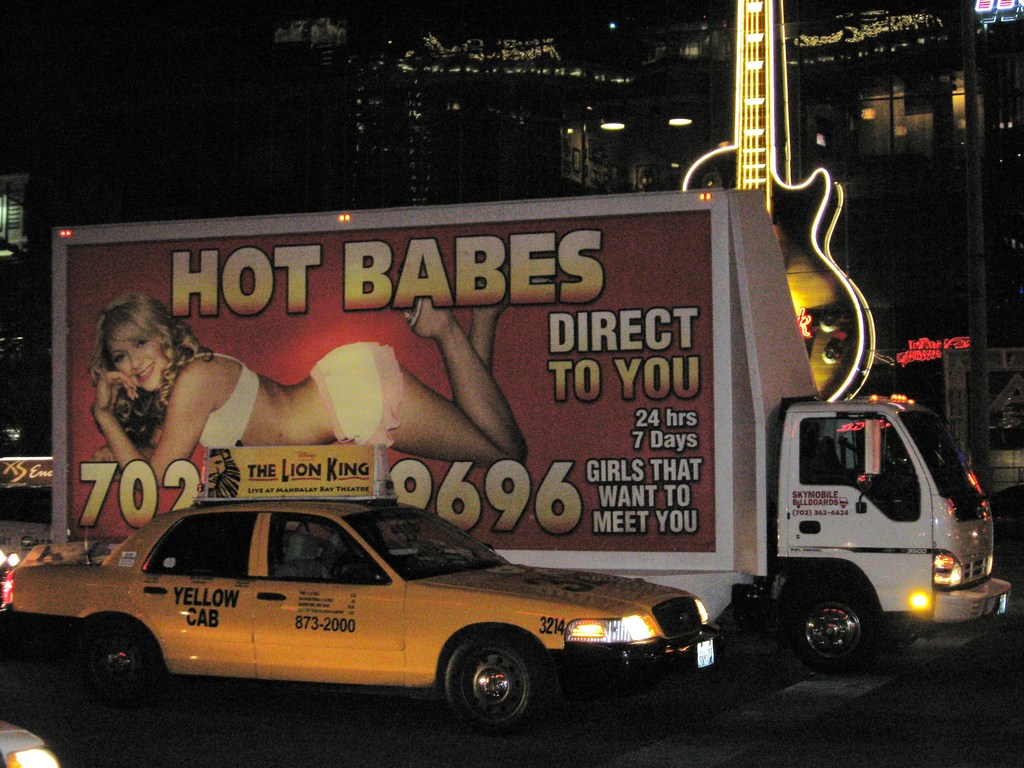What's happening in the scene? The image portrays a vibrant urban scene at night, featuring a large billboard truck displaying an eye-catching advertisement alongside a classic yellow taxi. The advertisement adds a bold pop of color and intrigue, likely aimed at capturing the attention of passersby and drivers. Furthermore, a unique large guitar sculpture illuminates part of the cityscape, enhancing the artistic and musical vibe of the area. This setting suggests the image was taken in a bustling area known for its nightlife and entertainment offerings. 